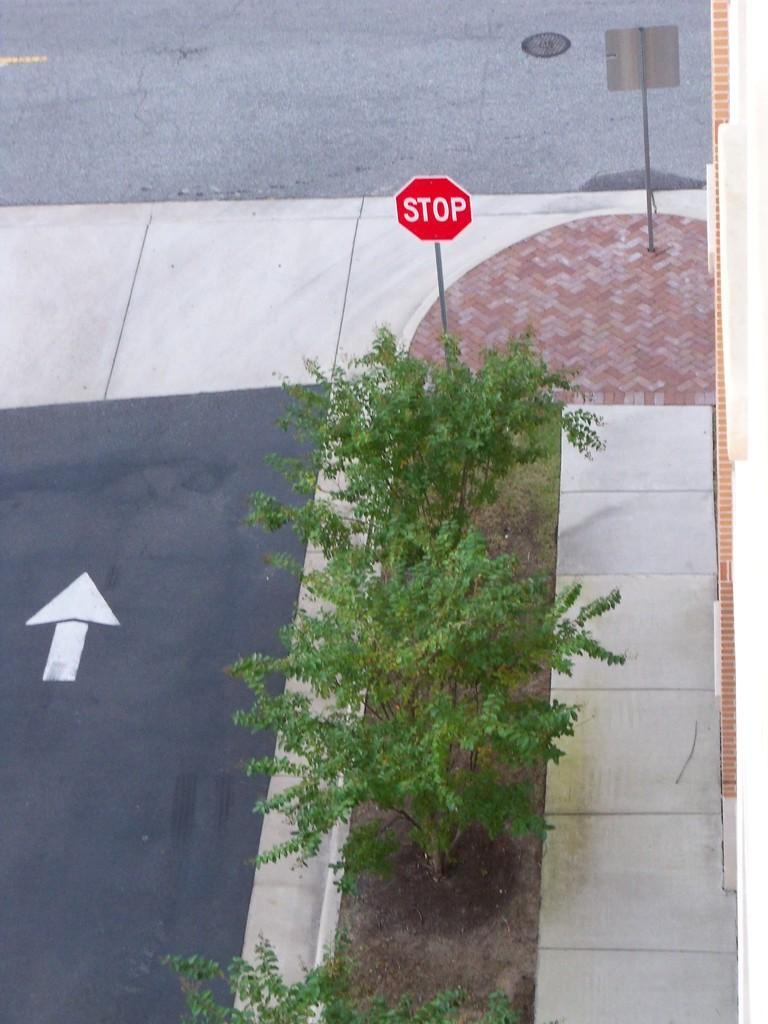<image>
Relay a brief, clear account of the picture shown. Road that contains a upward arrow and a stop sign on the sidewalk 